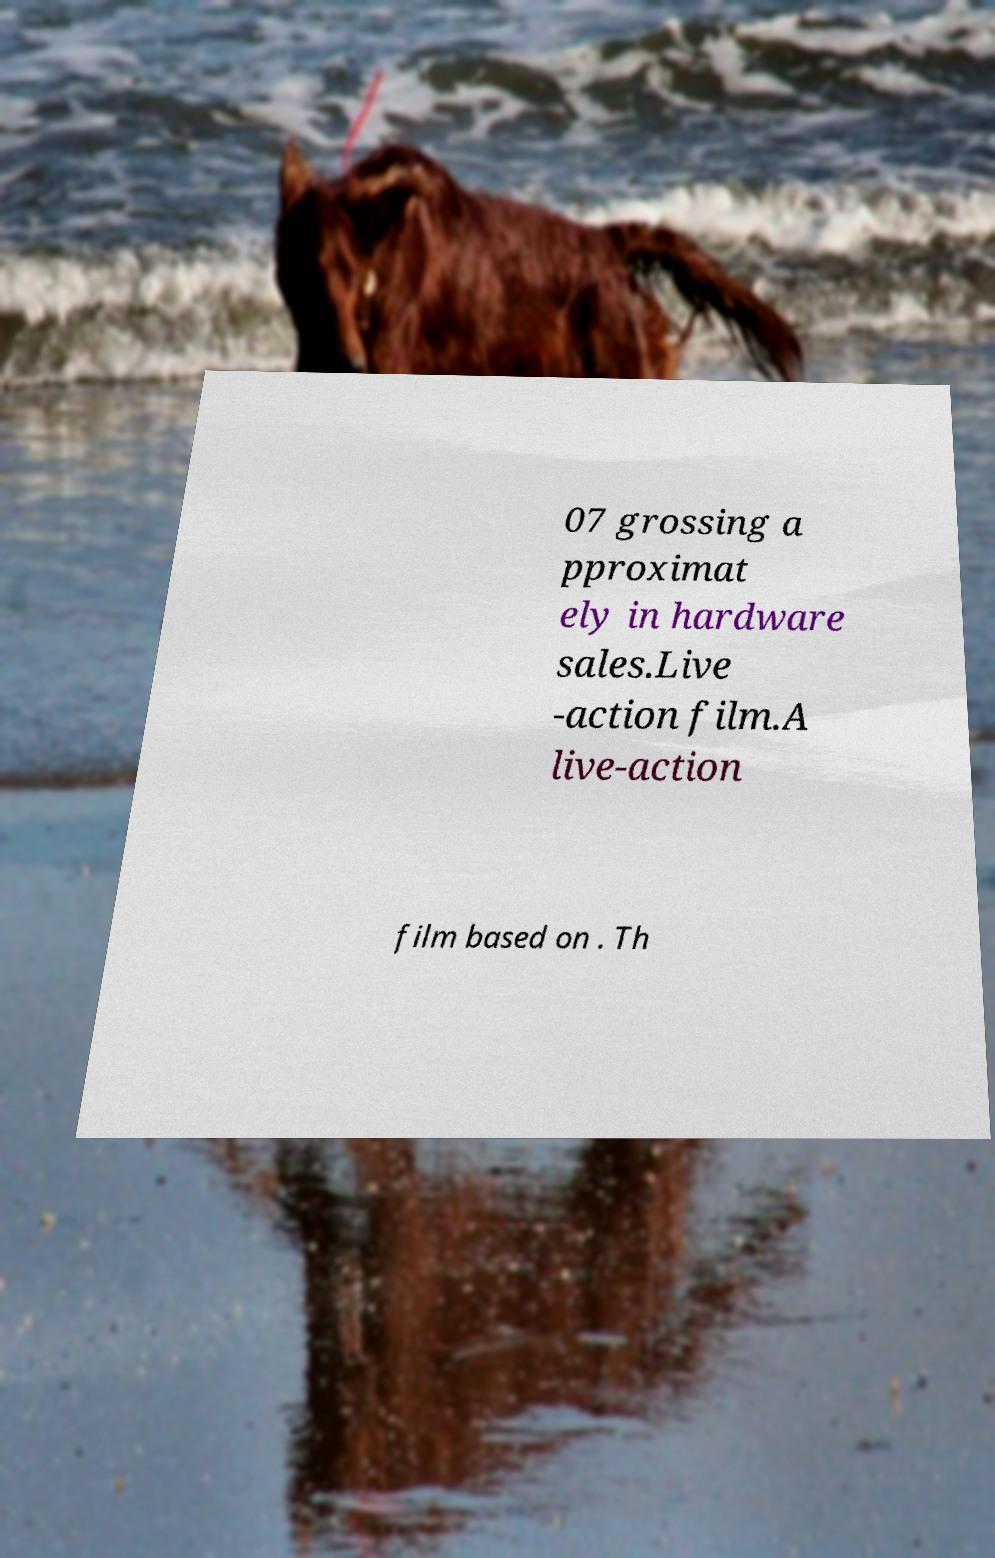Can you accurately transcribe the text from the provided image for me? 07 grossing a pproximat ely in hardware sales.Live -action film.A live-action film based on . Th 